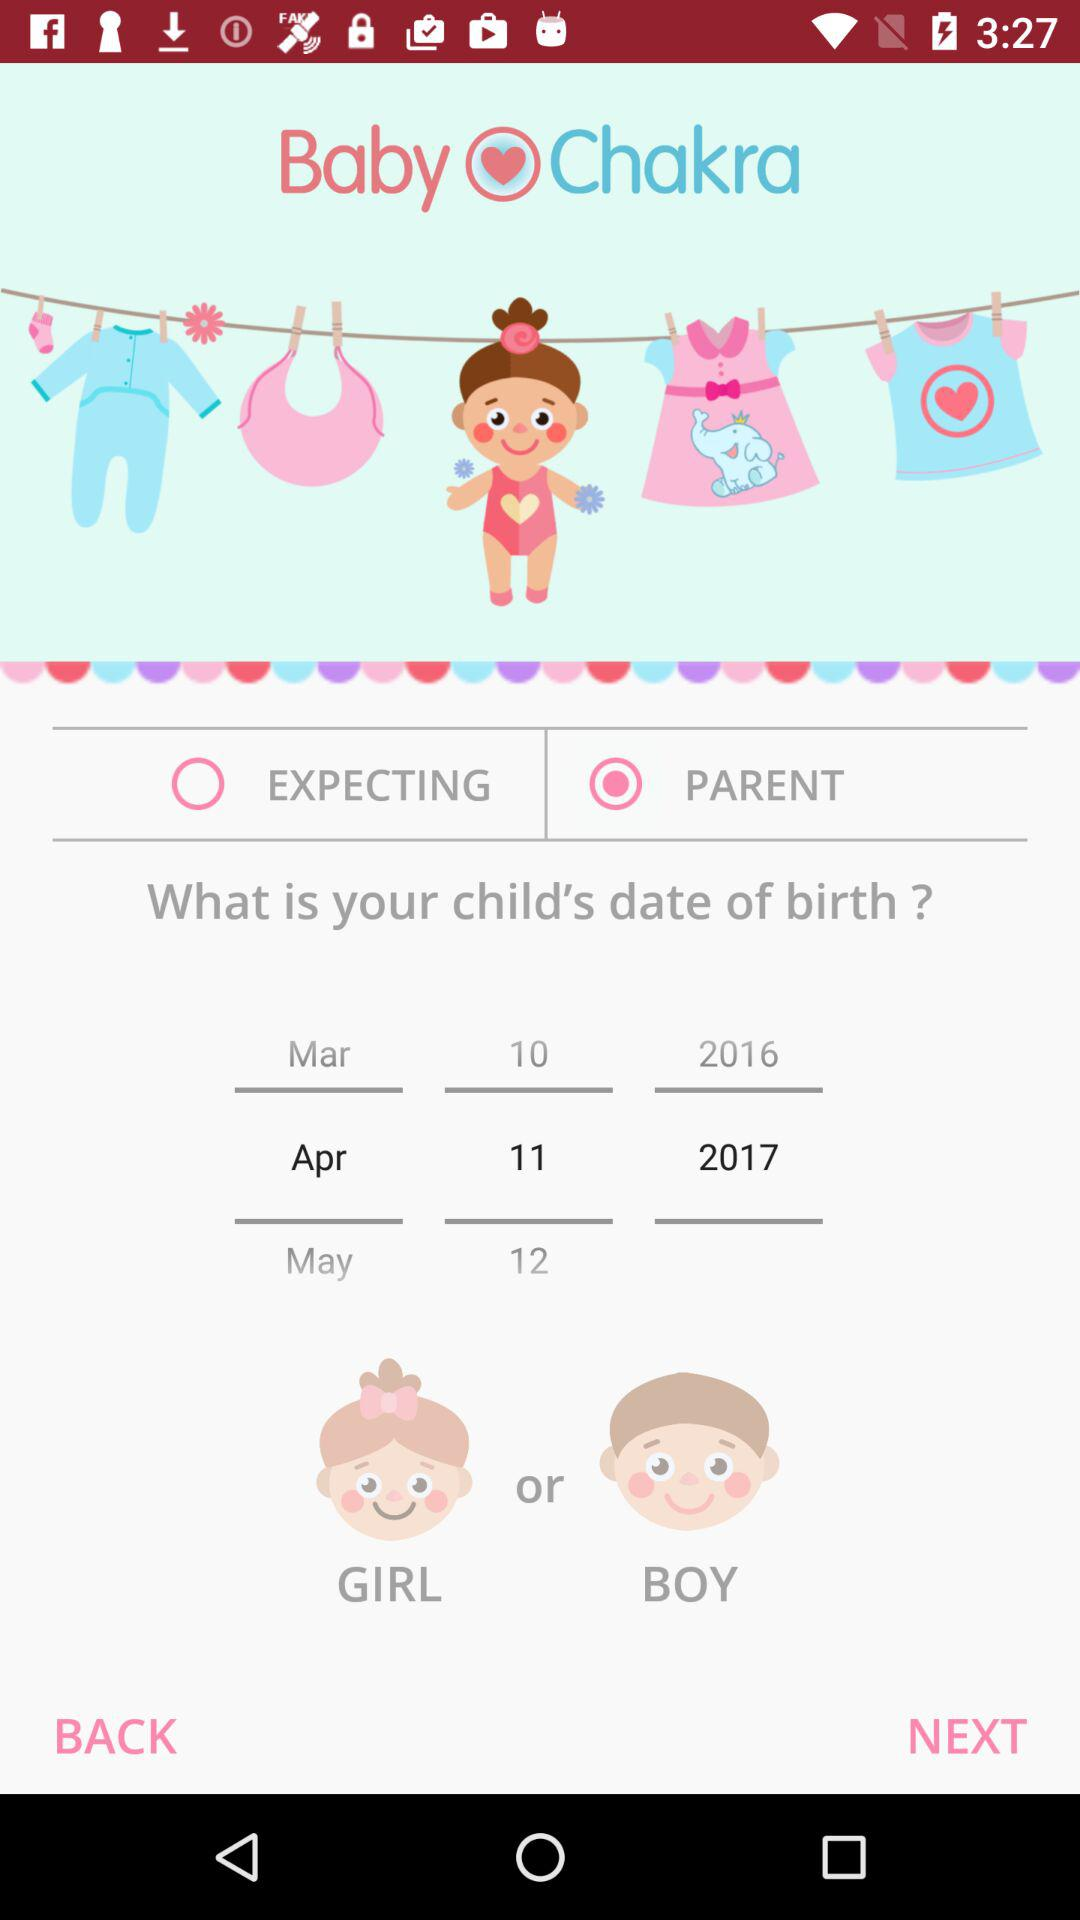What is the date of birth? The date of birth is April 11, 2017. 